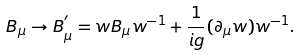<formula> <loc_0><loc_0><loc_500><loc_500>B _ { \mu } \rightarrow B ^ { ^ { \prime } } _ { \mu } = w B _ { \mu } w ^ { - 1 } + \frac { 1 } { i g } ( \partial _ { \mu } w ) w ^ { - 1 } .</formula> 